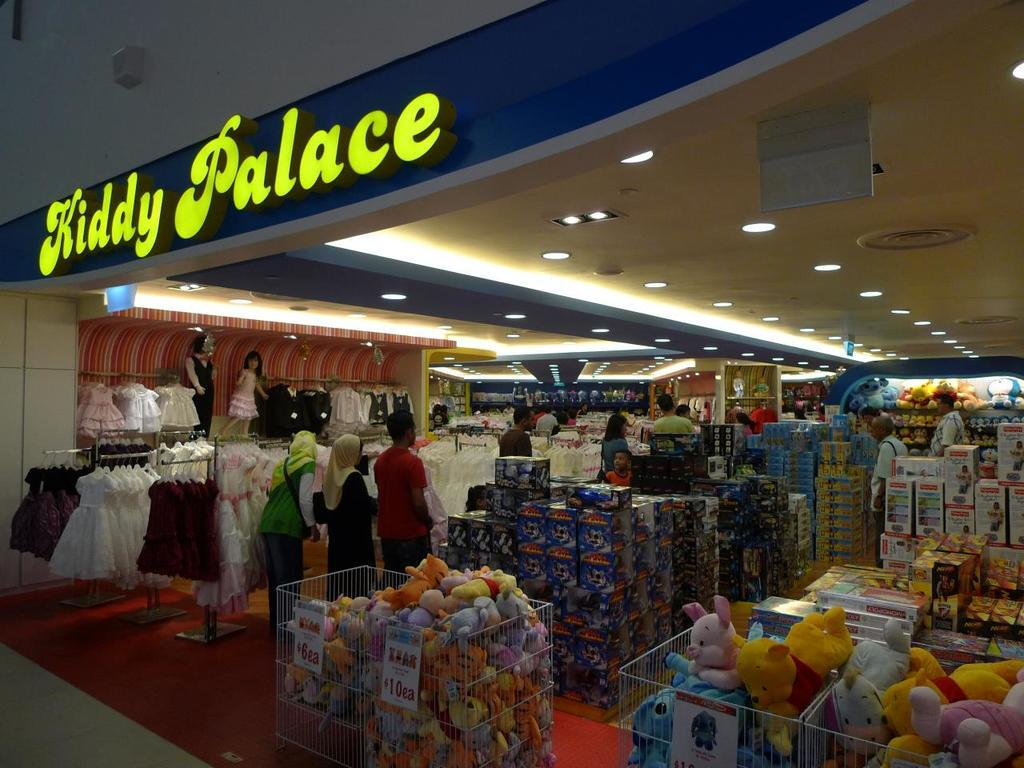Provide a one-sentence caption for the provided image. Looking into a clothing store called Kiddy Palace. 